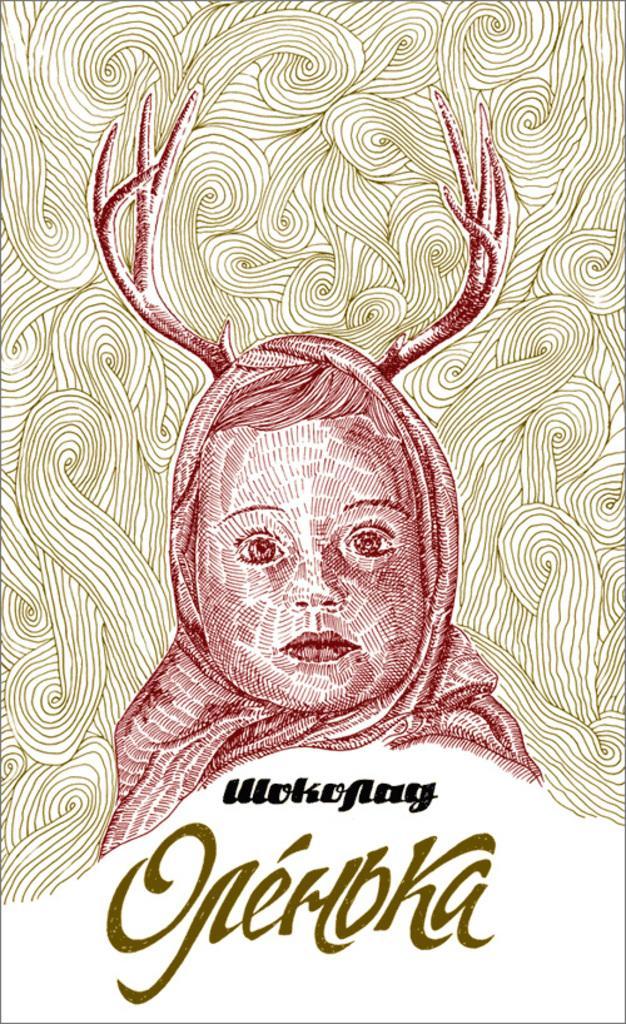Please provide a concise description of this image. This is a sketch. In the center of the image we can see a person's head. At the bottom of the image we can see the text. 